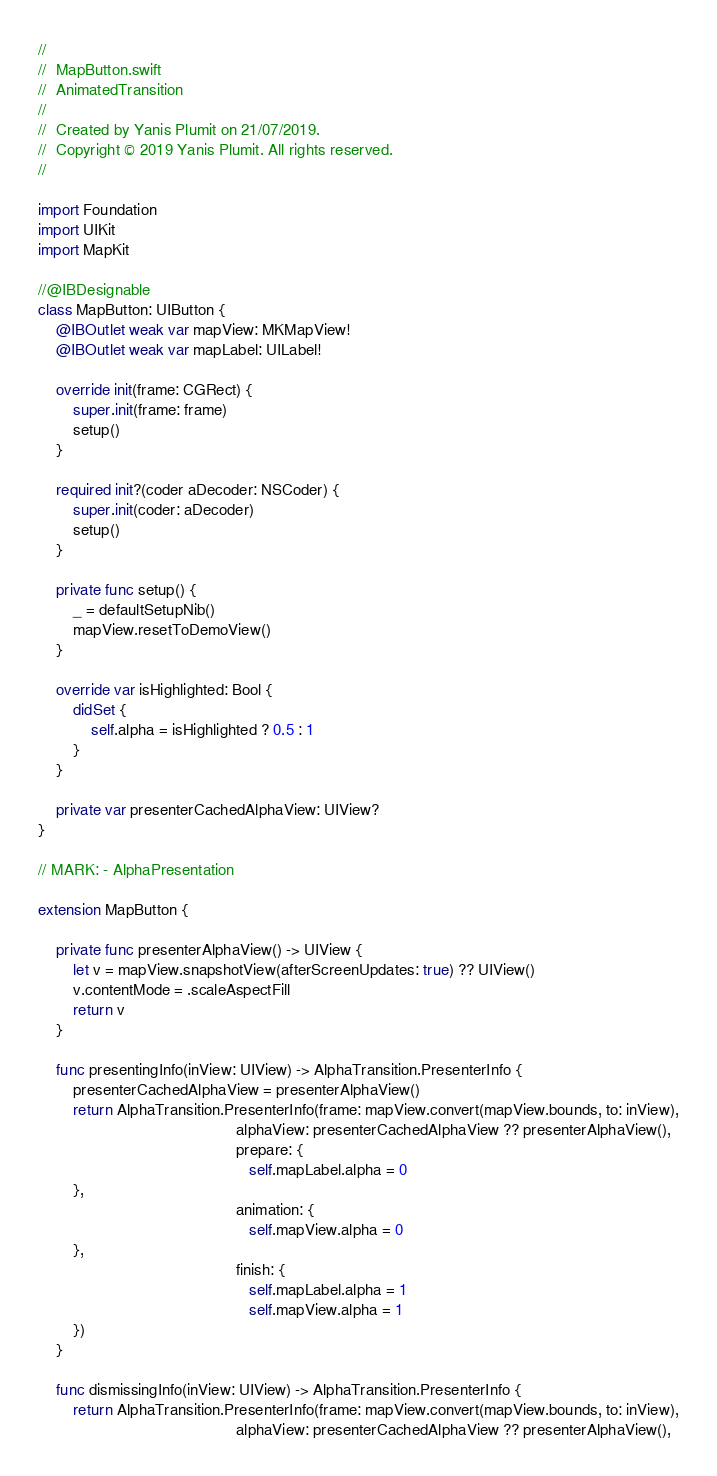Convert code to text. <code><loc_0><loc_0><loc_500><loc_500><_Swift_>//
//  MapButton.swift
//  AnimatedTransition
//
//  Created by Yanis Plumit on 21/07/2019.
//  Copyright © 2019 Yanis Plumit. All rights reserved.
//

import Foundation
import UIKit
import MapKit

//@IBDesignable
class MapButton: UIButton {
    @IBOutlet weak var mapView: MKMapView!
    @IBOutlet weak var mapLabel: UILabel!
    
    override init(frame: CGRect) {
        super.init(frame: frame)
        setup()
    }
    
    required init?(coder aDecoder: NSCoder) {
        super.init(coder: aDecoder)
        setup()
    }
    
    private func setup() {
        _ = defaultSetupNib()
        mapView.resetToDemoView()
    }
    
    override var isHighlighted: Bool {
        didSet {
            self.alpha = isHighlighted ? 0.5 : 1
        }
    }
    
    private var presenterCachedAlphaView: UIView?
}

// MARK: - AlphaPresentation

extension MapButton {
    
    private func presenterAlphaView() -> UIView {
        let v = mapView.snapshotView(afterScreenUpdates: true) ?? UIView()
        v.contentMode = .scaleAspectFill
        return v
    }
    
    func presentingInfo(inView: UIView) -> AlphaTransition.PresenterInfo {
        presenterCachedAlphaView = presenterAlphaView()
        return AlphaTransition.PresenterInfo(frame: mapView.convert(mapView.bounds, to: inView),
                                             alphaView: presenterCachedAlphaView ?? presenterAlphaView(),
                                             prepare: {
                                                self.mapLabel.alpha = 0
        },
                                             animation: {
                                                self.mapView.alpha = 0
        },
                                             finish: {
                                                self.mapLabel.alpha = 1
                                                self.mapView.alpha = 1
        })
    }
    
    func dismissingInfo(inView: UIView) -> AlphaTransition.PresenterInfo {
        return AlphaTransition.PresenterInfo(frame: mapView.convert(mapView.bounds, to: inView),
                                             alphaView: presenterCachedAlphaView ?? presenterAlphaView(),</code> 